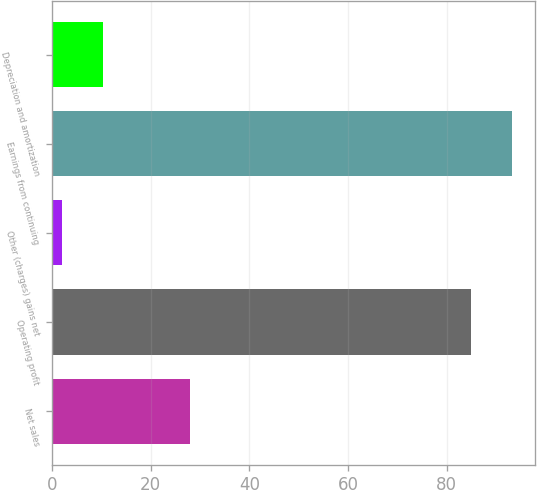Convert chart to OTSL. <chart><loc_0><loc_0><loc_500><loc_500><bar_chart><fcel>Net sales<fcel>Operating profit<fcel>Other (charges) gains net<fcel>Earnings from continuing<fcel>Depreciation and amortization<nl><fcel>28<fcel>85<fcel>2<fcel>93.3<fcel>10.3<nl></chart> 